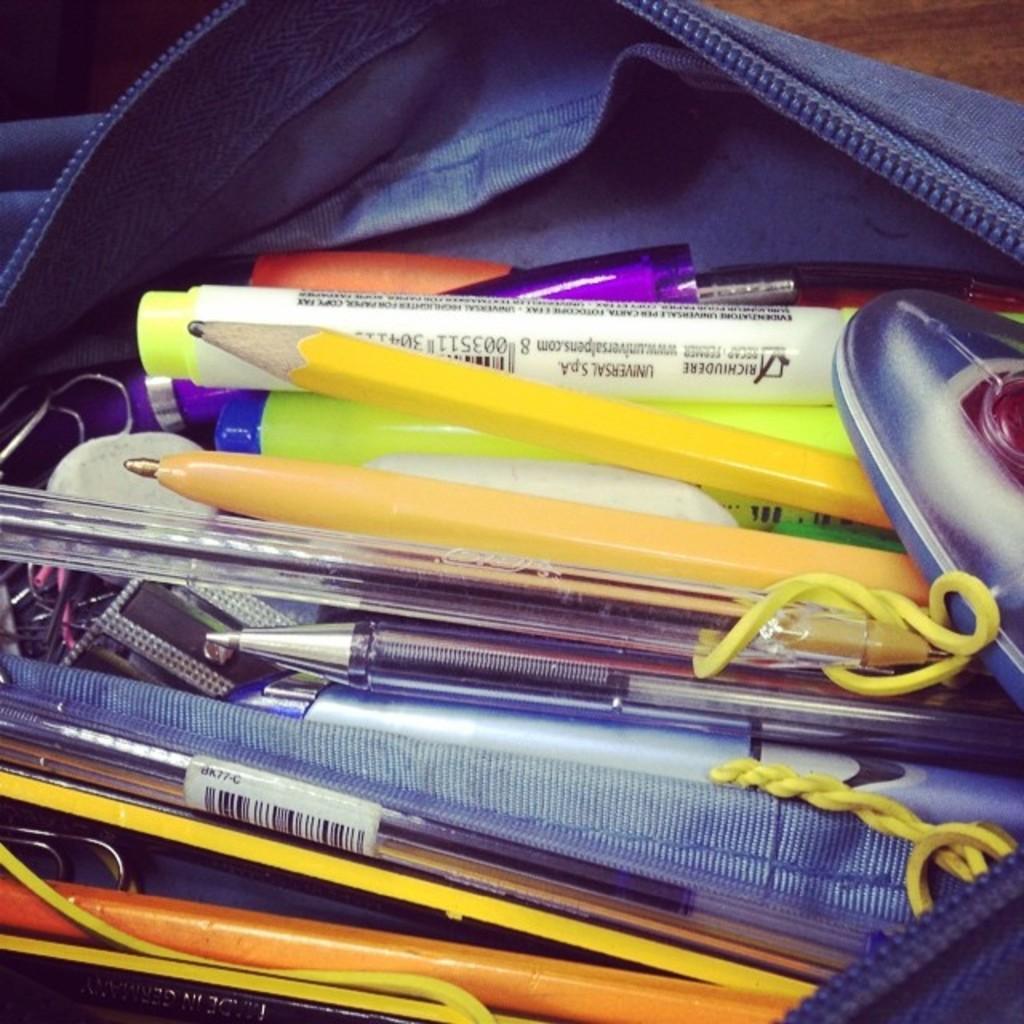Please provide a concise description of this image. In this picture we can see a pouch with pens, pencils, some objects in it and this pack is placed is on the wooden surface. 